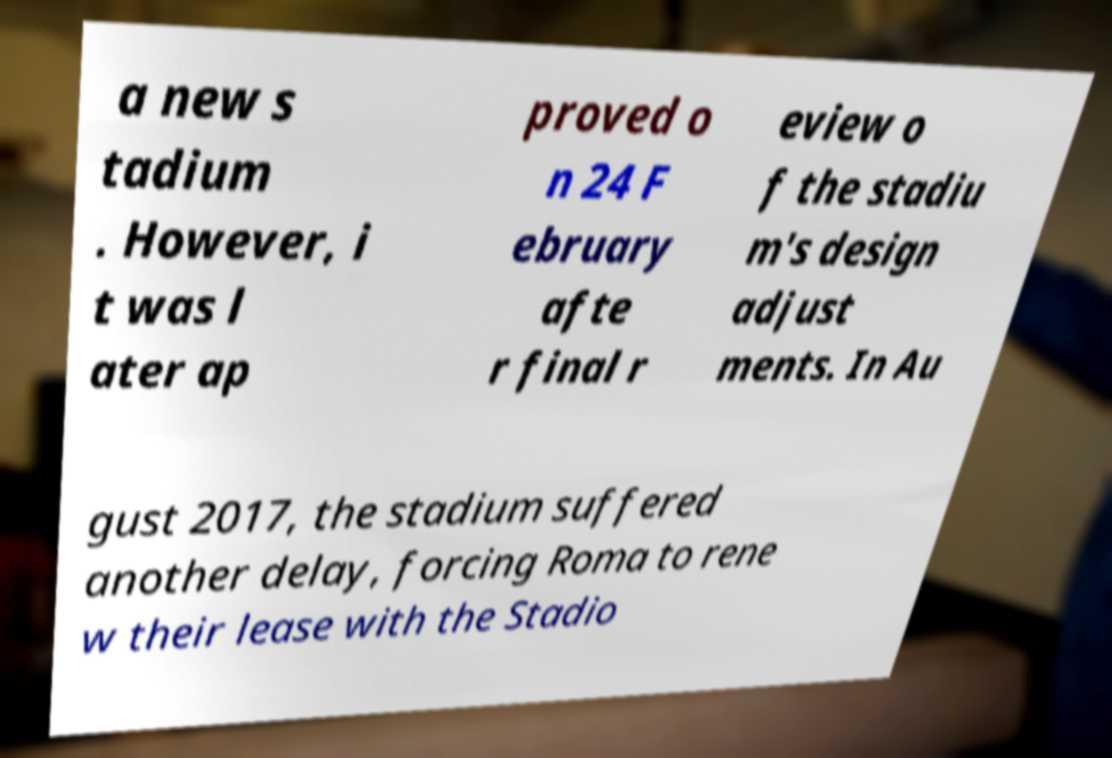What messages or text are displayed in this image? I need them in a readable, typed format. a new s tadium . However, i t was l ater ap proved o n 24 F ebruary afte r final r eview o f the stadiu m's design adjust ments. In Au gust 2017, the stadium suffered another delay, forcing Roma to rene w their lease with the Stadio 